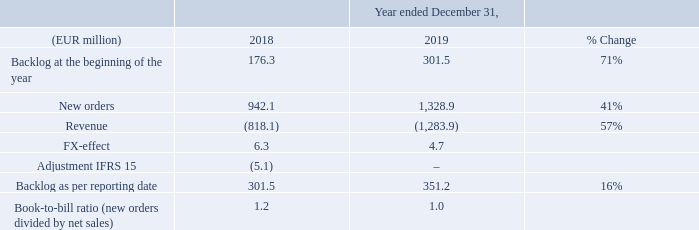BOOKINGS
The following table shows new orders levels for 2019 and the backlog for 2018:
The backlog includes orders for which purchase orders or letters of intent have been accepted, typically for up to one year. Historically, orders have been subject to cancellation or rescheduling by customers. In addition, orders have been subject to price negotiations and changes in specifications as a result of changes in customers’ requirements. Due to possible customer changes in delivery schedules and requirements, and to cancellations of orders, our backlog at any particular date is not necessarily indicative of actual sales for any subsequent period.
For the year in total, our new bookings increased by 24% in 2019 to €1,170 million, excluding the proceeds from the settlements. The book-to-bill, as measured by orders divided by revenue, was 1.0 in 2019. Equipment bookings were led by the foundry segment, followed by logic and memory. Bookings strengthened in the course of the year, excluding the settlement gains, from €235 million in the first quarter to €270 million in the second quarter, €292 million in the third quarter and finished at a new record high of €373 million in the fourth quarter. We also finished the year with a record high order backlog of €351 million, an increase of 16% compared to the end of 2018.
What was the percentage increase in new bookings in 2019 for the year in total? 24%. What does the table show? New orders levels for 2019 and the backlog for 2018. What is the % change in Backlog at the beginning of the year from 2018 to 2019? 71%. What is the average Backlog at the beginning of the year for both 2018 and 2019?
Answer scale should be: million. (176.3+301.5)/2
Answer: 238.9. What is the percentage change in Bookings, excluding the settlement gains of first quarter 2019 to second quarter?
Answer scale should be: percent. (270-235)/235
Answer: 14.89. What is the percentage change in Bookings, excluding the settlement gains, of the first two quarters 2019 to last two quarters?
Answer scale should be: percent. (373+292-270-235)/(235+270)
Answer: 31.68. 